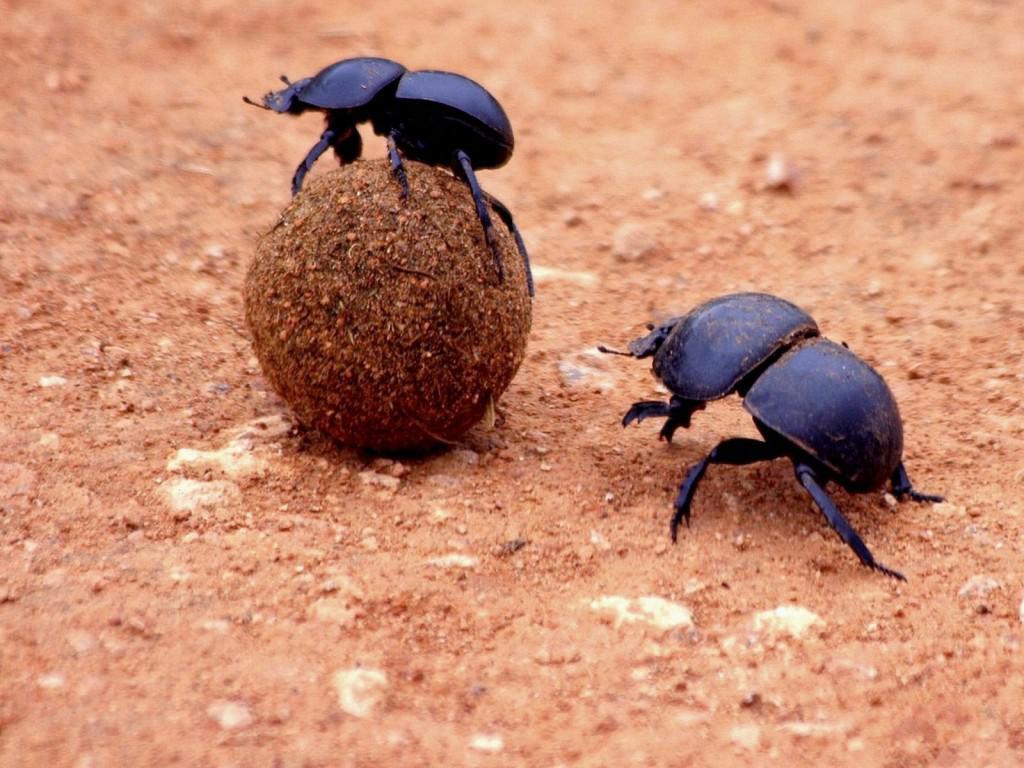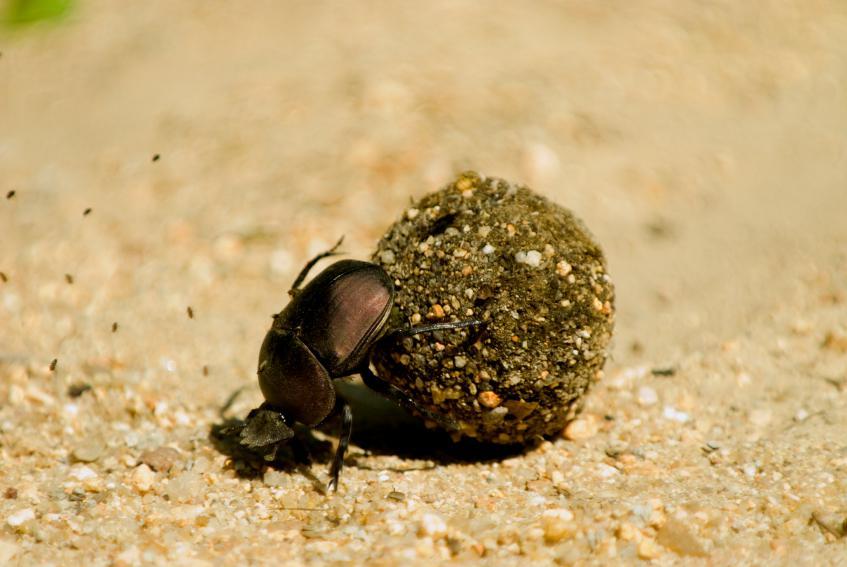The first image is the image on the left, the second image is the image on the right. For the images shown, is this caption "An image of a beetle includes a thumb and fingers." true? Answer yes or no. No. The first image is the image on the left, the second image is the image on the right. Assess this claim about the two images: "The right image contains a human hand interacting with a dung beetle.". Correct or not? Answer yes or no. No. 